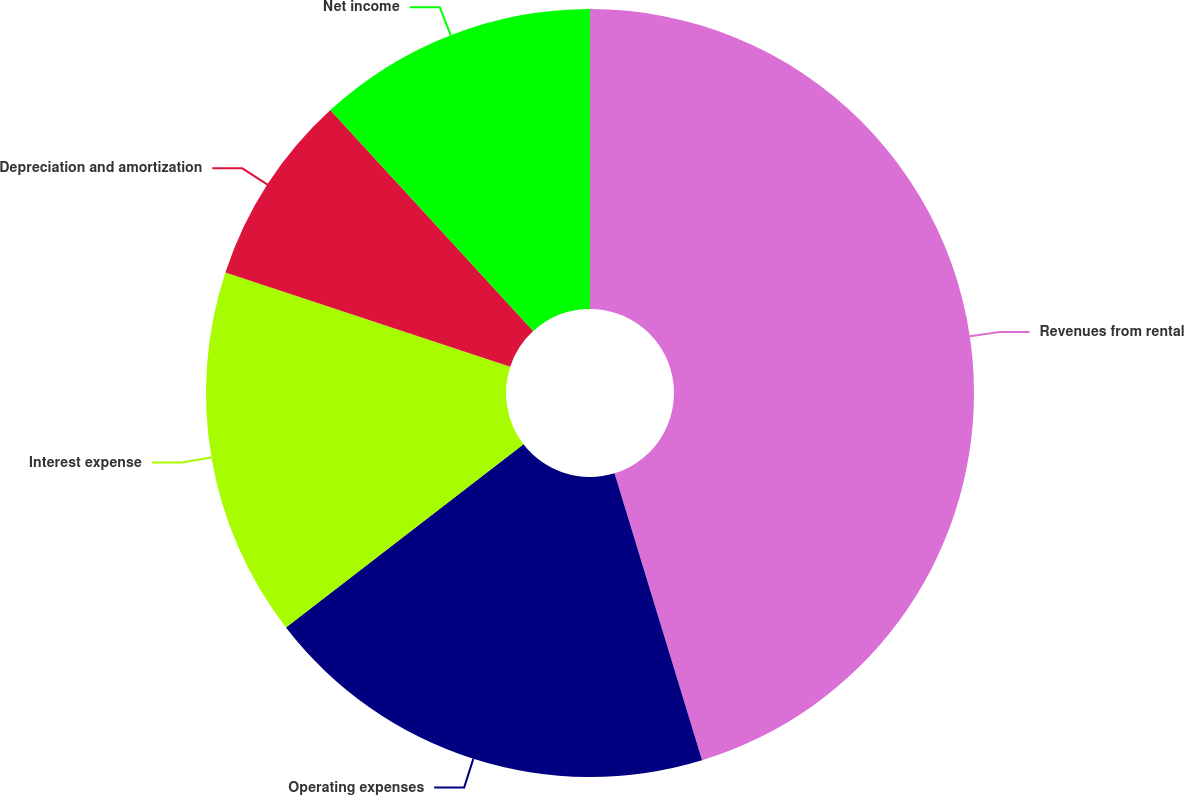<chart> <loc_0><loc_0><loc_500><loc_500><pie_chart><fcel>Revenues from rental<fcel>Operating expenses<fcel>Interest expense<fcel>Depreciation and amortization<fcel>Net income<nl><fcel>45.29%<fcel>19.26%<fcel>15.54%<fcel>8.1%<fcel>11.82%<nl></chart> 